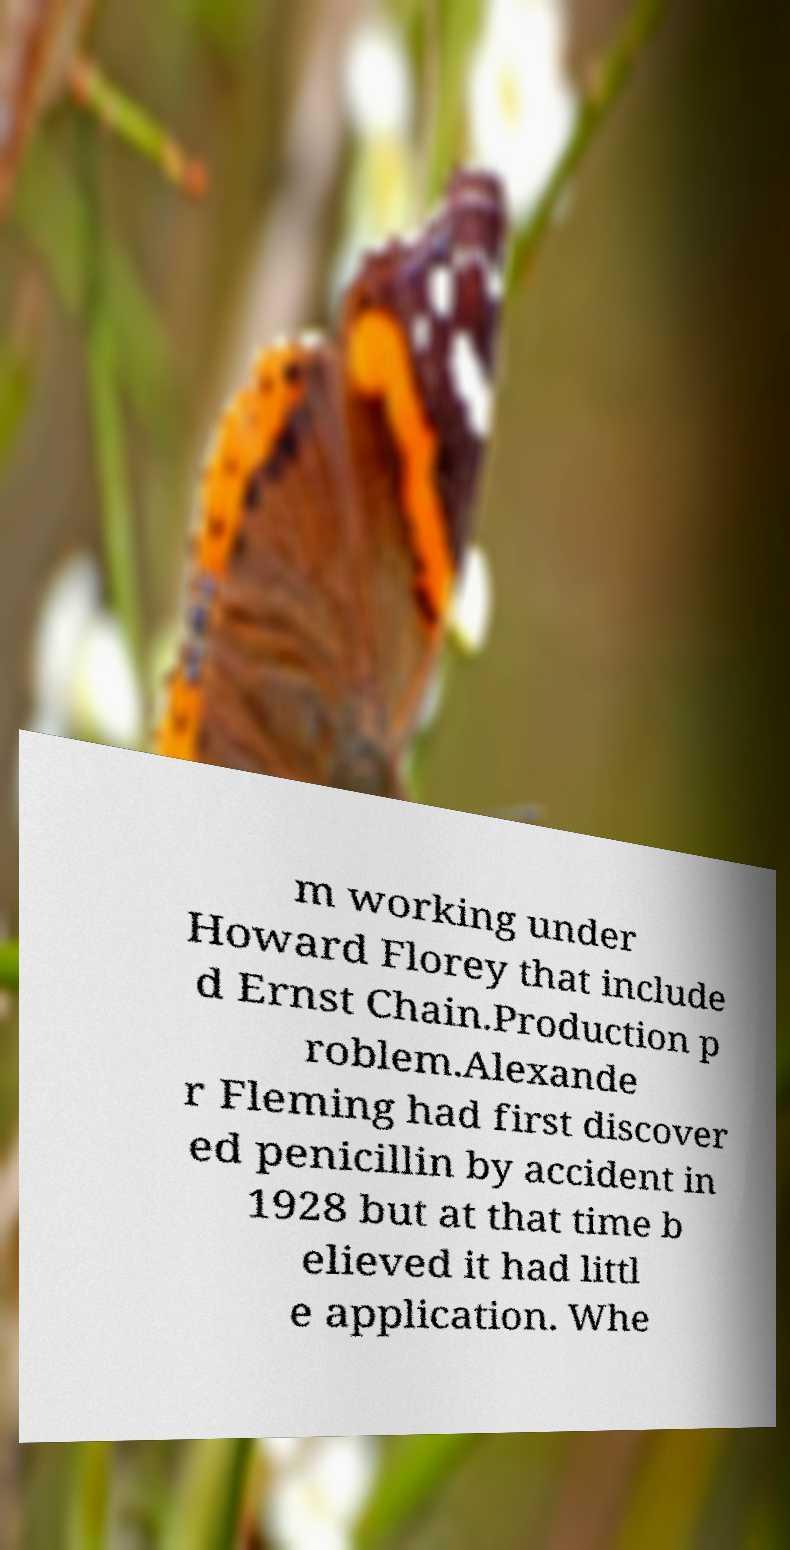I need the written content from this picture converted into text. Can you do that? m working under Howard Florey that include d Ernst Chain.Production p roblem.Alexande r Fleming had first discover ed penicillin by accident in 1928 but at that time b elieved it had littl e application. Whe 